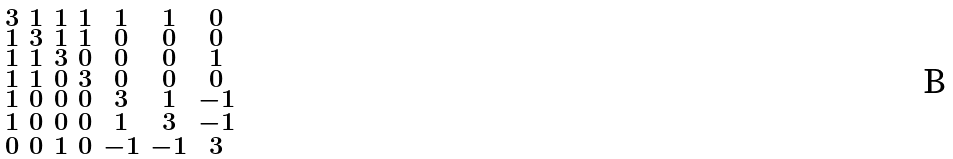<formula> <loc_0><loc_0><loc_500><loc_500>\begin{smallmatrix} 3 & 1 & 1 & 1 & 1 & 1 & 0 \\ 1 & 3 & 1 & 1 & 0 & 0 & 0 \\ 1 & 1 & 3 & 0 & 0 & 0 & 1 \\ 1 & 1 & 0 & 3 & 0 & 0 & 0 \\ 1 & 0 & 0 & 0 & 3 & 1 & - 1 \\ 1 & 0 & 0 & 0 & 1 & 3 & - 1 \\ 0 & 0 & 1 & 0 & - 1 & - 1 & 3 \end{smallmatrix}</formula> 